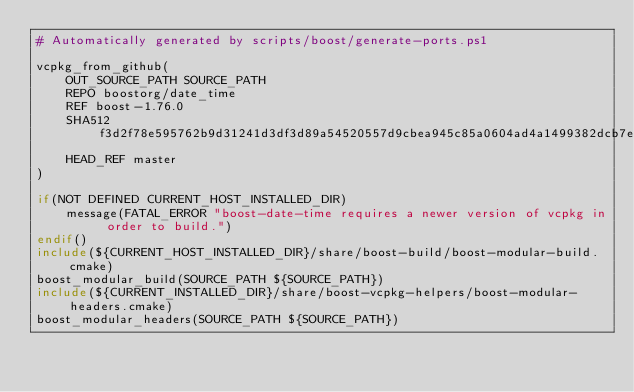Convert code to text. <code><loc_0><loc_0><loc_500><loc_500><_CMake_># Automatically generated by scripts/boost/generate-ports.ps1

vcpkg_from_github(
    OUT_SOURCE_PATH SOURCE_PATH
    REPO boostorg/date_time
    REF boost-1.76.0
    SHA512 f3d2f78e595762b9d31241d3df3d89a54520557d9cbea945c85a0604ad4a1499382dcb7e55e2c33e45908cbca71d9eb36c9bf72ce1392b7dc24ee34e3b18ba02
    HEAD_REF master
)

if(NOT DEFINED CURRENT_HOST_INSTALLED_DIR)
    message(FATAL_ERROR "boost-date-time requires a newer version of vcpkg in order to build.")
endif()
include(${CURRENT_HOST_INSTALLED_DIR}/share/boost-build/boost-modular-build.cmake)
boost_modular_build(SOURCE_PATH ${SOURCE_PATH})
include(${CURRENT_INSTALLED_DIR}/share/boost-vcpkg-helpers/boost-modular-headers.cmake)
boost_modular_headers(SOURCE_PATH ${SOURCE_PATH})
</code> 